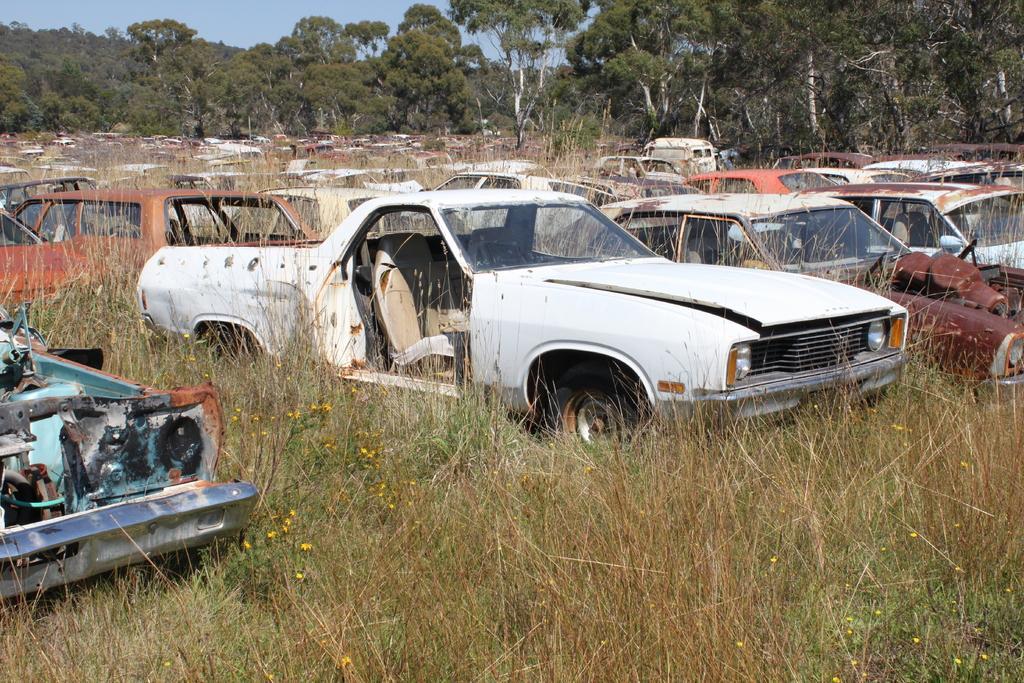In one or two sentences, can you explain what this image depicts? In this image we can see so many cars on the grassy land. In the background, we can see trees and the sky. 